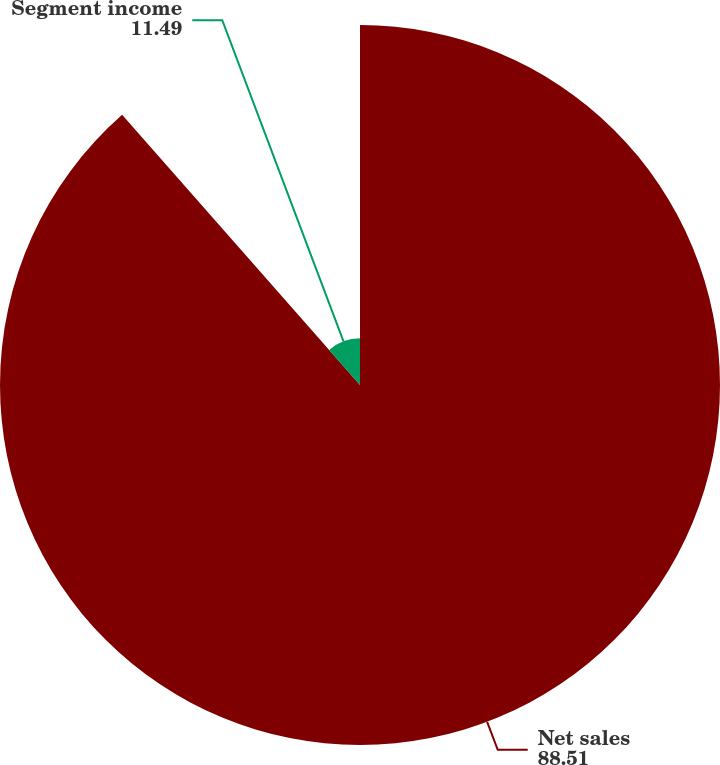<chart> <loc_0><loc_0><loc_500><loc_500><pie_chart><fcel>Net sales<fcel>Segment income<nl><fcel>88.51%<fcel>11.49%<nl></chart> 